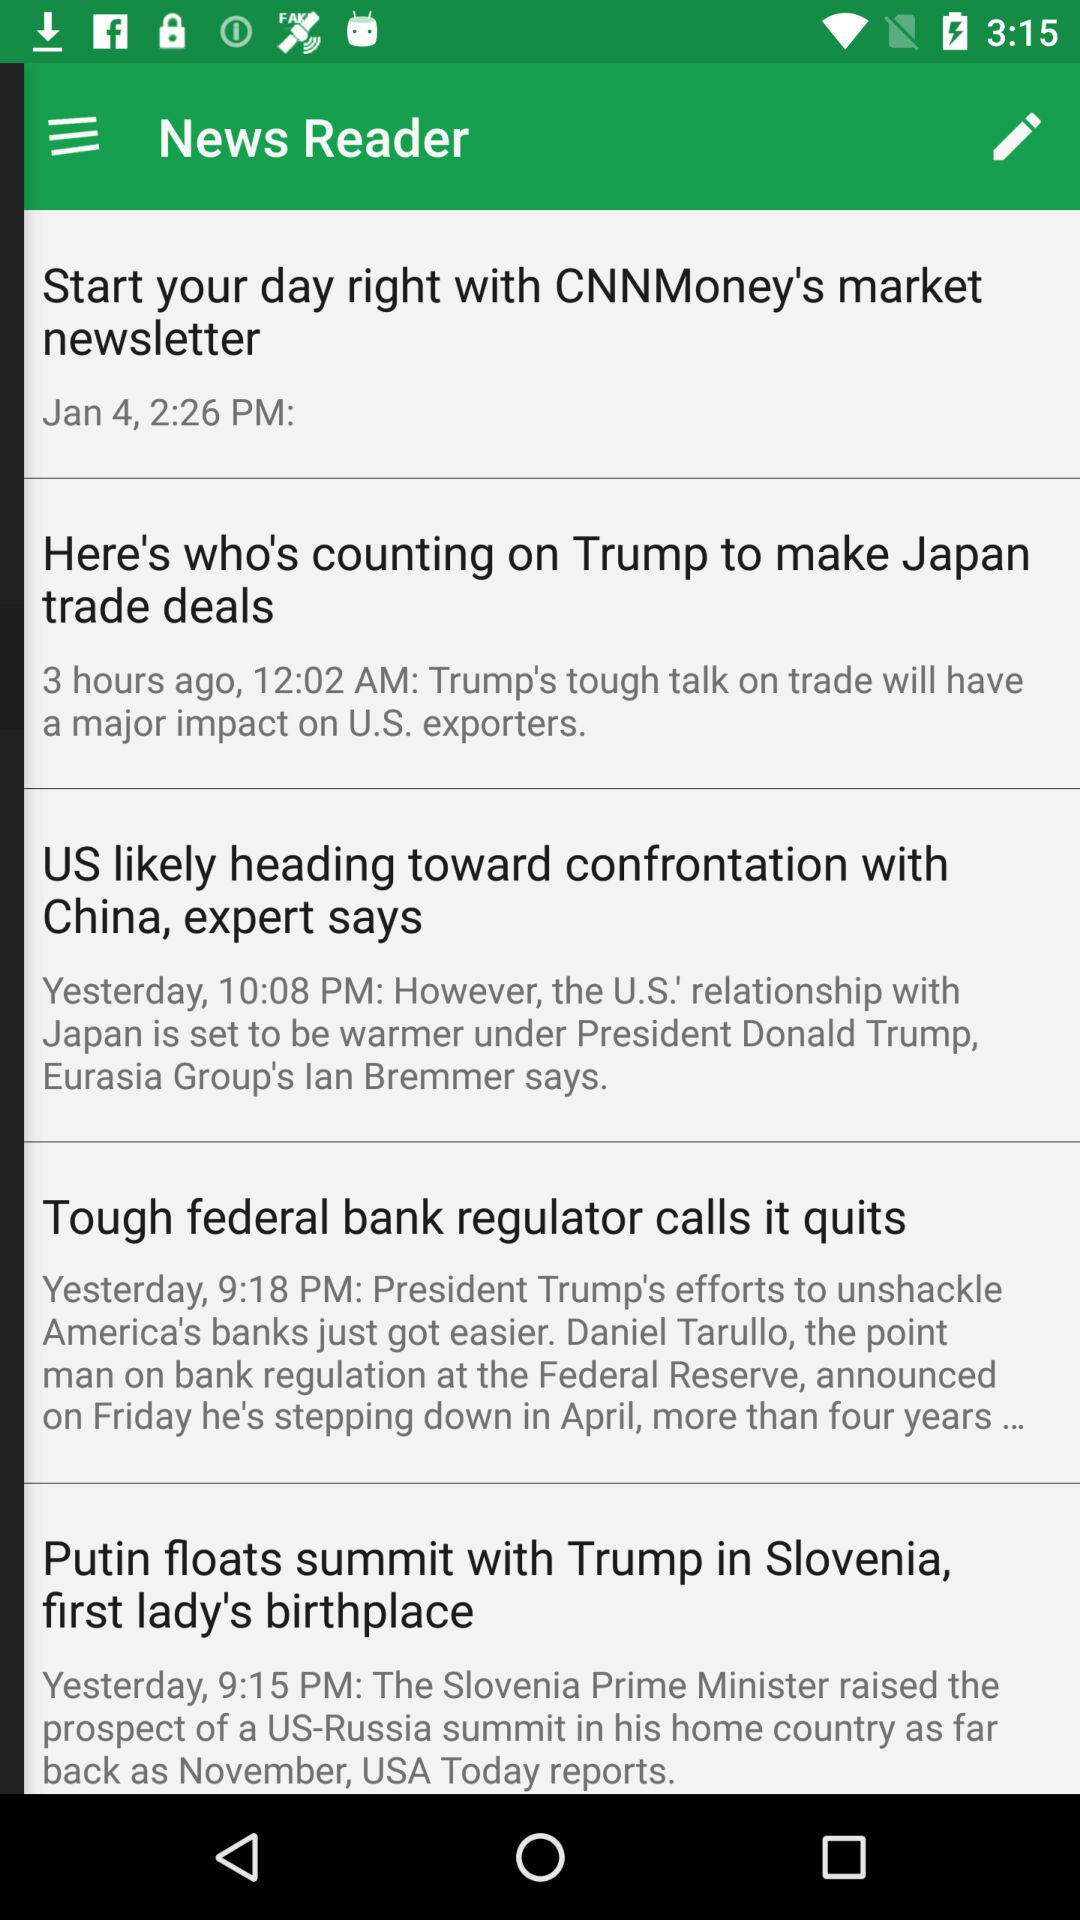What is the publication time of the news "Tough federal bank regulator calls it quits"? The publication time of the news "Tough federal bank regulator calls it quits" is 9:18 PM. 